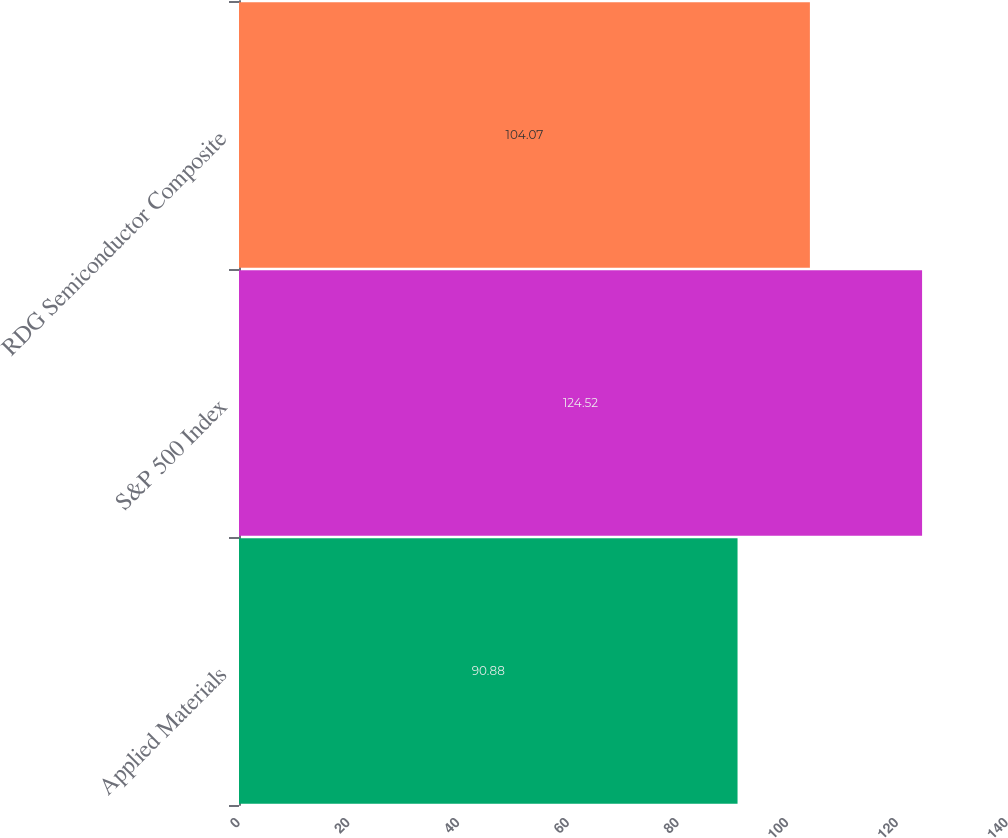Convert chart. <chart><loc_0><loc_0><loc_500><loc_500><bar_chart><fcel>Applied Materials<fcel>S&P 500 Index<fcel>RDG Semiconductor Composite<nl><fcel>90.88<fcel>124.52<fcel>104.07<nl></chart> 